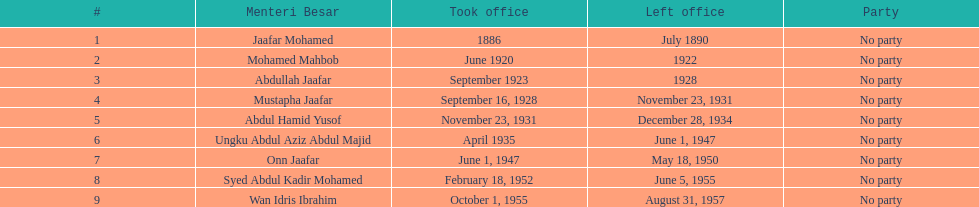Mention a person whose tenure in office was less than four years. Mohamed Mahbob. 